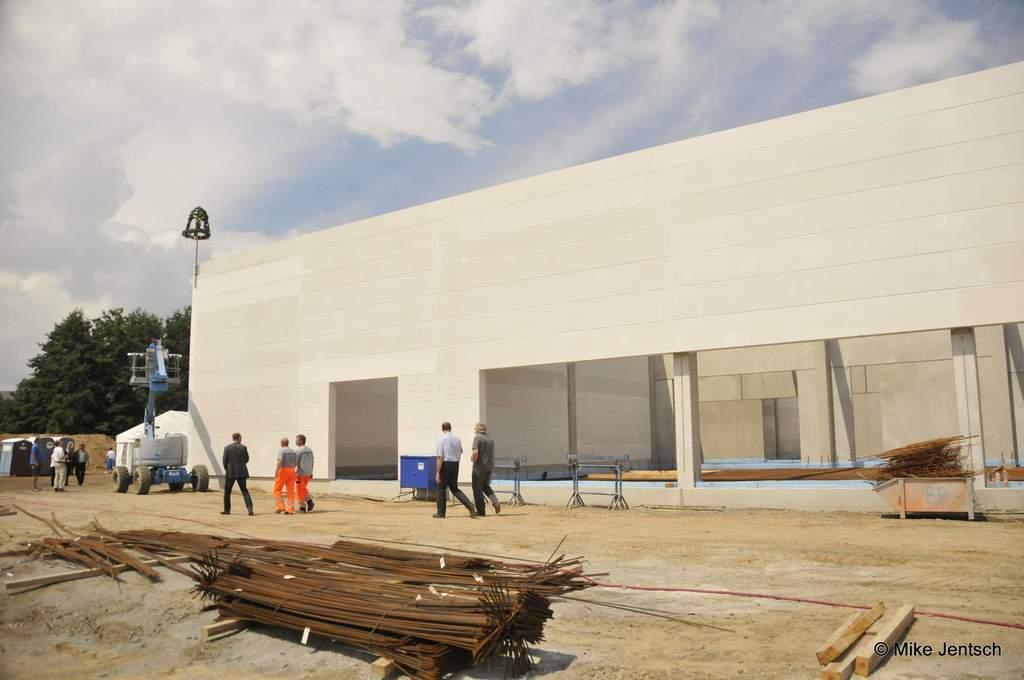Can you describe this image briefly? In the center of the image there is a building and a tree. At the bottom there are metal rods and pillars. We can see people walking and there is a vehicle. In the background there is sky. On the right there is a trolley. 